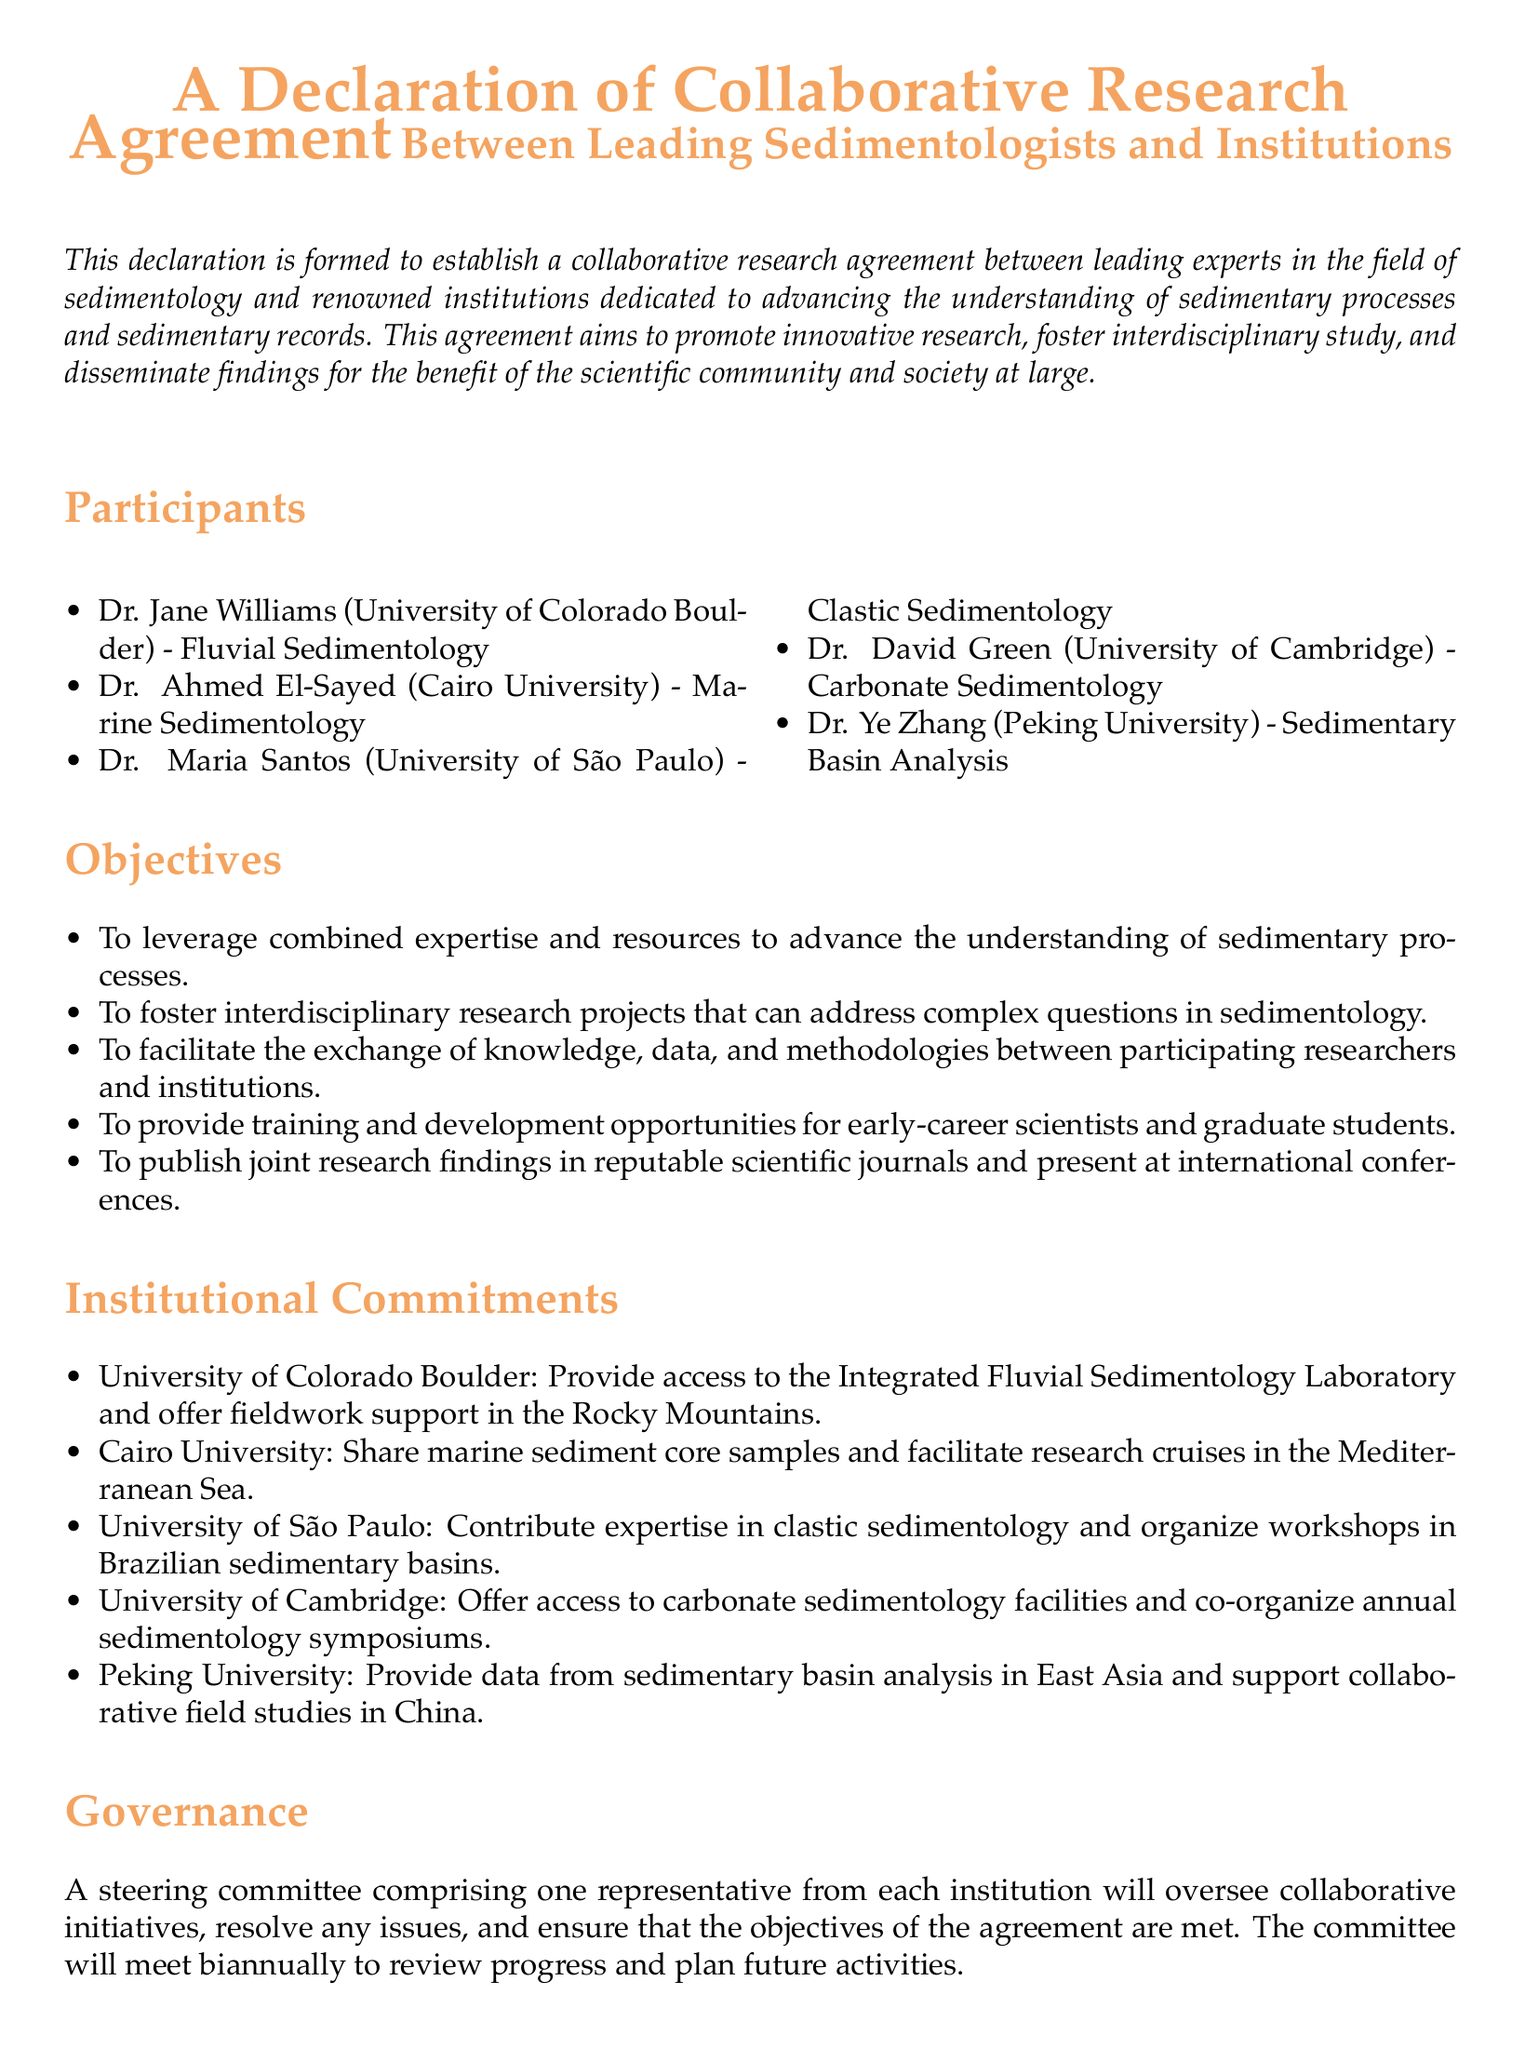What is the main purpose of the declaration? The main purpose is to establish a collaborative research agreement to advance understanding of sedimentary processes.
Answer: Collaborative research agreement How many leading sedimentologists are listed as participants? The document lists five leading sedimentologists as participants.
Answer: Five Which institution is associated with Dr. Ahmed El-Sayed? Dr. Ahmed El-Sayed is associated with Cairo University.
Answer: Cairo University What support will the University of Colorado Boulder provide? The University of Colorado Boulder will provide access to the Integrated Fluvial Sedimentology Laboratory and fieldwork support.
Answer: Fieldwork support How often will the steering committee meet? The steering committee will meet biannually to review progress.
Answer: Biannually What is the initial duration of the agreement? The initial duration of the agreement is five years.
Answer: Five years Who is responsible for overseeing collaborative initiatives? A steering committee comprising one representative from each institution is responsible.
Answer: Steering committee What type of sedimentology does Dr. David Green specialize in? Dr. David Green specializes in Carbonate Sedimentology.
Answer: Carbonate Sedimentology What is one objective of the collaborative research agreement? One objective is to foster interdisciplinary research projects.
Answer: Interdisciplinary research projects 